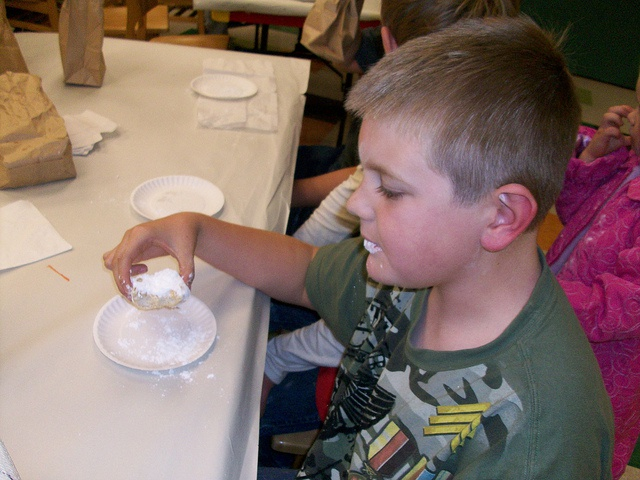Describe the objects in this image and their specific colors. I can see people in maroon, gray, black, and darkgray tones, dining table in maroon, tan, lightgray, and darkgray tones, people in maroon and purple tones, people in maroon, black, gray, and darkgray tones, and donut in maroon, lavender, darkgray, tan, and lightgray tones in this image. 